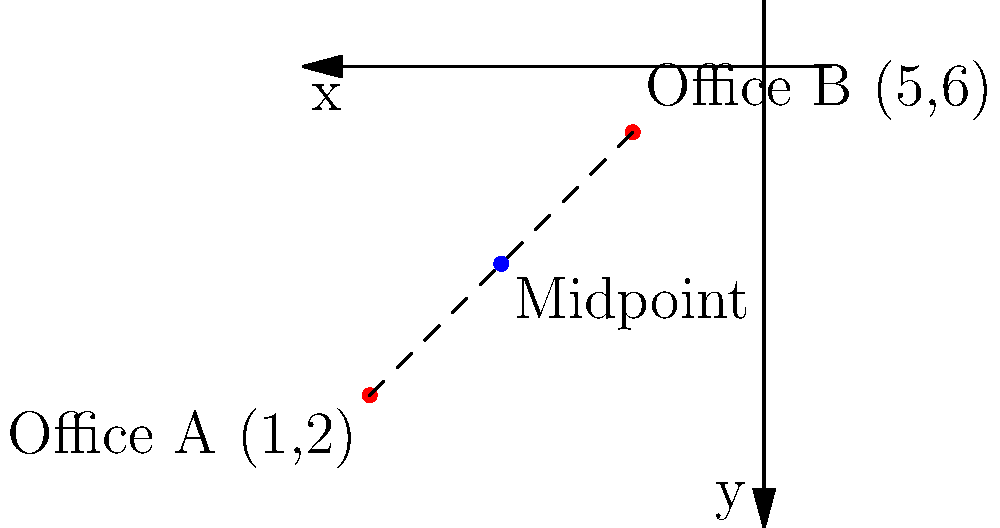Two social service offices are located on a coordinate plane. Office A is at (1,2) and Office B is at (5,6). You need to find a central location that is equidistant from both offices for a community meeting. What are the coordinates of the midpoint between these two offices? To find the midpoint between two points, we can use the midpoint formula:

$$ \text{Midpoint} = \left(\frac{x_1 + x_2}{2}, \frac{y_1 + y_2}{2}\right) $$

Where $(x_1, y_1)$ are the coordinates of the first point and $(x_2, y_2)$ are the coordinates of the second point.

Let's apply this formula to our problem:

1. Office A coordinates: $(x_1, y_1) = (1, 2)$
2. Office B coordinates: $(x_2, y_2) = (5, 6)$

Now, let's calculate the x-coordinate of the midpoint:
$$ x = \frac{x_1 + x_2}{2} = \frac{1 + 5}{2} = \frac{6}{2} = 3 $$

Next, let's calculate the y-coordinate of the midpoint:
$$ y = \frac{y_1 + y_2}{2} = \frac{2 + 6}{2} = \frac{8}{2} = 4 $$

Therefore, the midpoint coordinates are (3, 4).
Answer: (3, 4) 